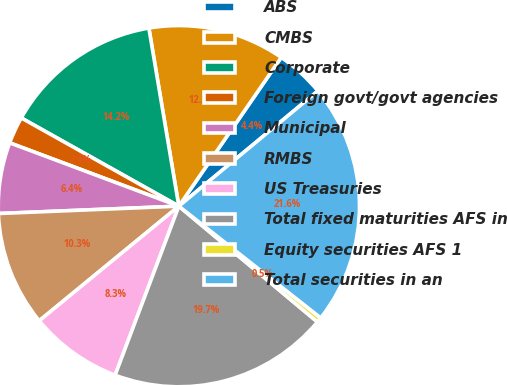<chart> <loc_0><loc_0><loc_500><loc_500><pie_chart><fcel>ABS<fcel>CMBS<fcel>Corporate<fcel>Foreign govt/govt agencies<fcel>Municipal<fcel>RMBS<fcel>US Treasuries<fcel>Total fixed maturities AFS in<fcel>Equity securities AFS 1<fcel>Total securities in an<nl><fcel>4.39%<fcel>12.25%<fcel>14.22%<fcel>2.42%<fcel>6.35%<fcel>10.29%<fcel>8.32%<fcel>19.66%<fcel>0.46%<fcel>21.63%<nl></chart> 